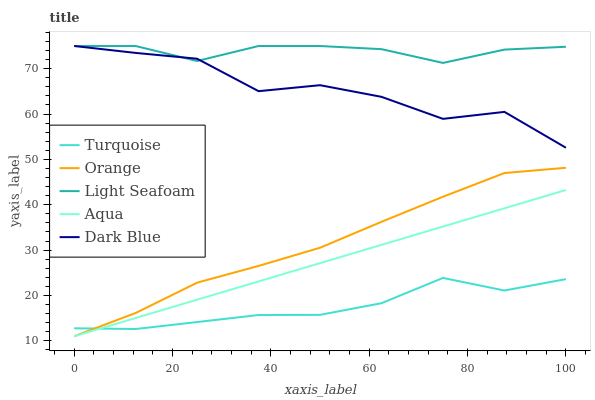Does Turquoise have the minimum area under the curve?
Answer yes or no. Yes. Does Light Seafoam have the maximum area under the curve?
Answer yes or no. Yes. Does Dark Blue have the minimum area under the curve?
Answer yes or no. No. Does Dark Blue have the maximum area under the curve?
Answer yes or no. No. Is Aqua the smoothest?
Answer yes or no. Yes. Is Dark Blue the roughest?
Answer yes or no. Yes. Is Turquoise the smoothest?
Answer yes or no. No. Is Turquoise the roughest?
Answer yes or no. No. Does Orange have the lowest value?
Answer yes or no. Yes. Does Dark Blue have the lowest value?
Answer yes or no. No. Does Light Seafoam have the highest value?
Answer yes or no. Yes. Does Turquoise have the highest value?
Answer yes or no. No. Is Aqua less than Dark Blue?
Answer yes or no. Yes. Is Dark Blue greater than Turquoise?
Answer yes or no. Yes. Does Aqua intersect Turquoise?
Answer yes or no. Yes. Is Aqua less than Turquoise?
Answer yes or no. No. Is Aqua greater than Turquoise?
Answer yes or no. No. Does Aqua intersect Dark Blue?
Answer yes or no. No. 